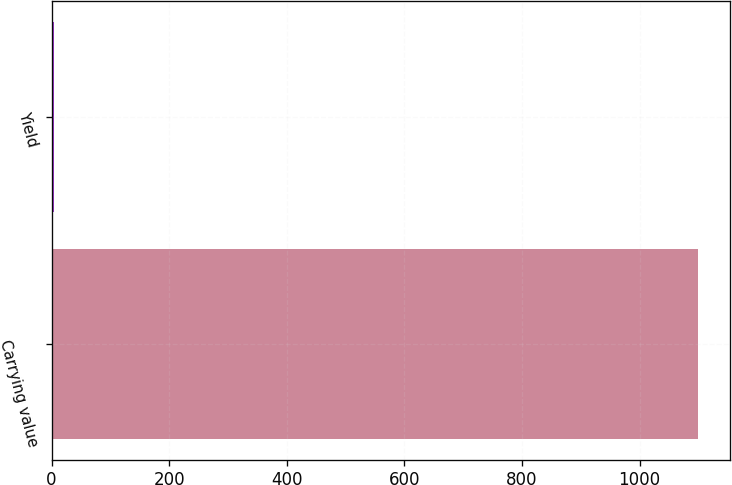Convert chart. <chart><loc_0><loc_0><loc_500><loc_500><bar_chart><fcel>Carrying value<fcel>Yield<nl><fcel>1099<fcel>4.38<nl></chart> 